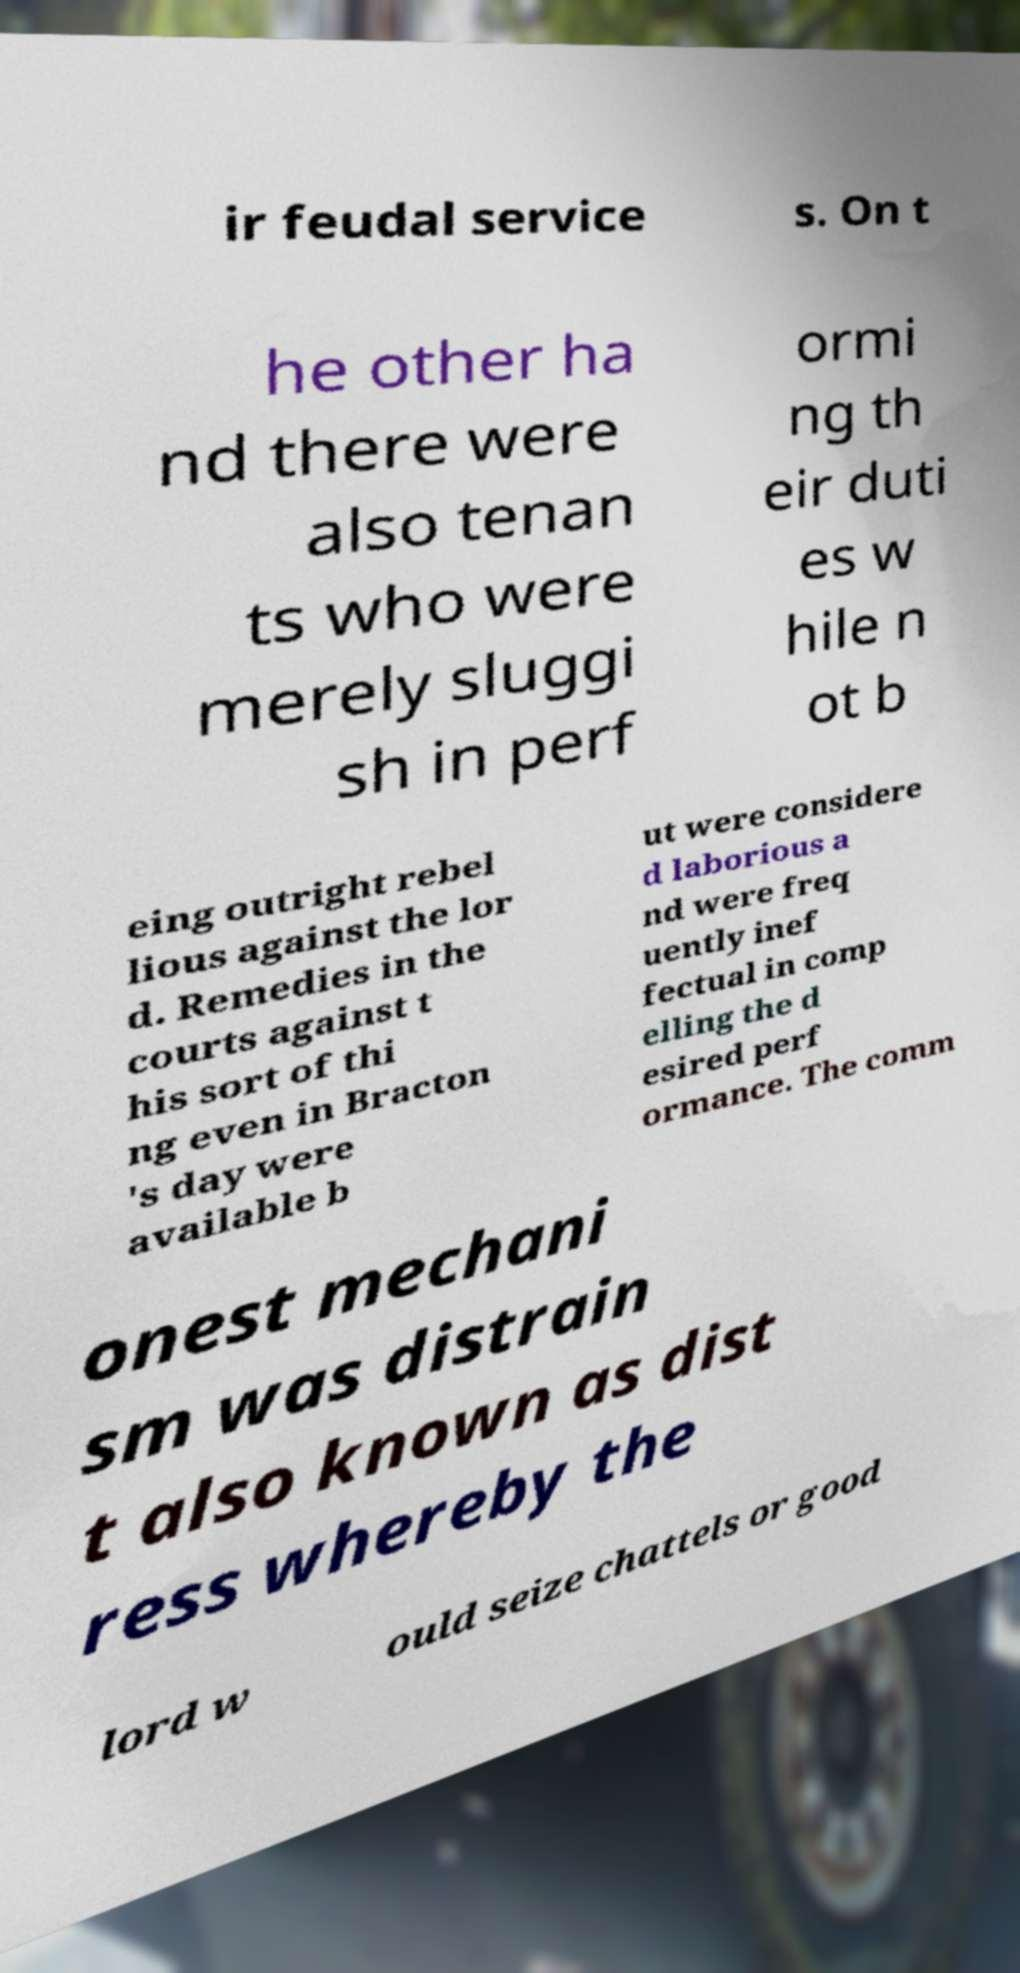Could you assist in decoding the text presented in this image and type it out clearly? ir feudal service s. On t he other ha nd there were also tenan ts who were merely sluggi sh in perf ormi ng th eir duti es w hile n ot b eing outright rebel lious against the lor d. Remedies in the courts against t his sort of thi ng even in Bracton 's day were available b ut were considere d laborious a nd were freq uently inef fectual in comp elling the d esired perf ormance. The comm onest mechani sm was distrain t also known as dist ress whereby the lord w ould seize chattels or good 